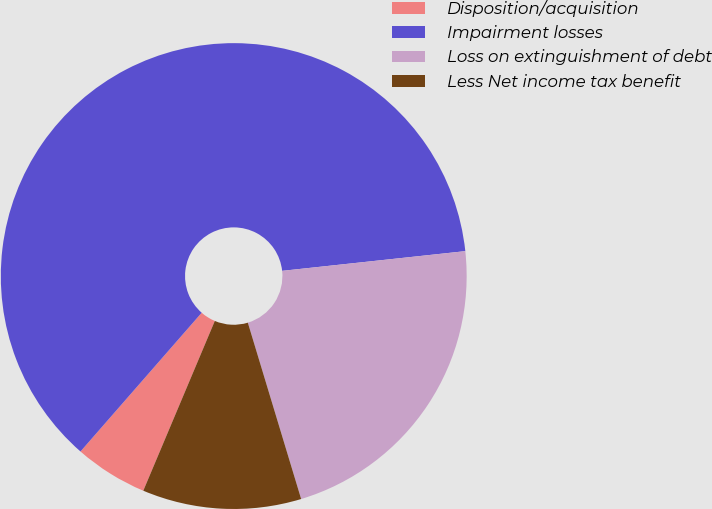<chart> <loc_0><loc_0><loc_500><loc_500><pie_chart><fcel>Disposition/acquisition<fcel>Impairment losses<fcel>Loss on extinguishment of debt<fcel>Less Net income tax benefit<nl><fcel>5.08%<fcel>61.86%<fcel>22.03%<fcel>11.02%<nl></chart> 